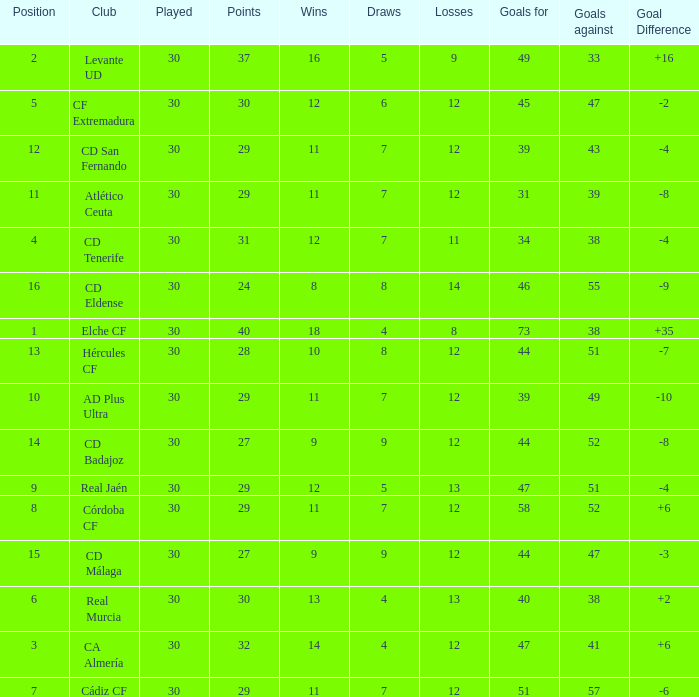What is the lowest amount of draws with less than 12 wins and less than 30 played? None. 